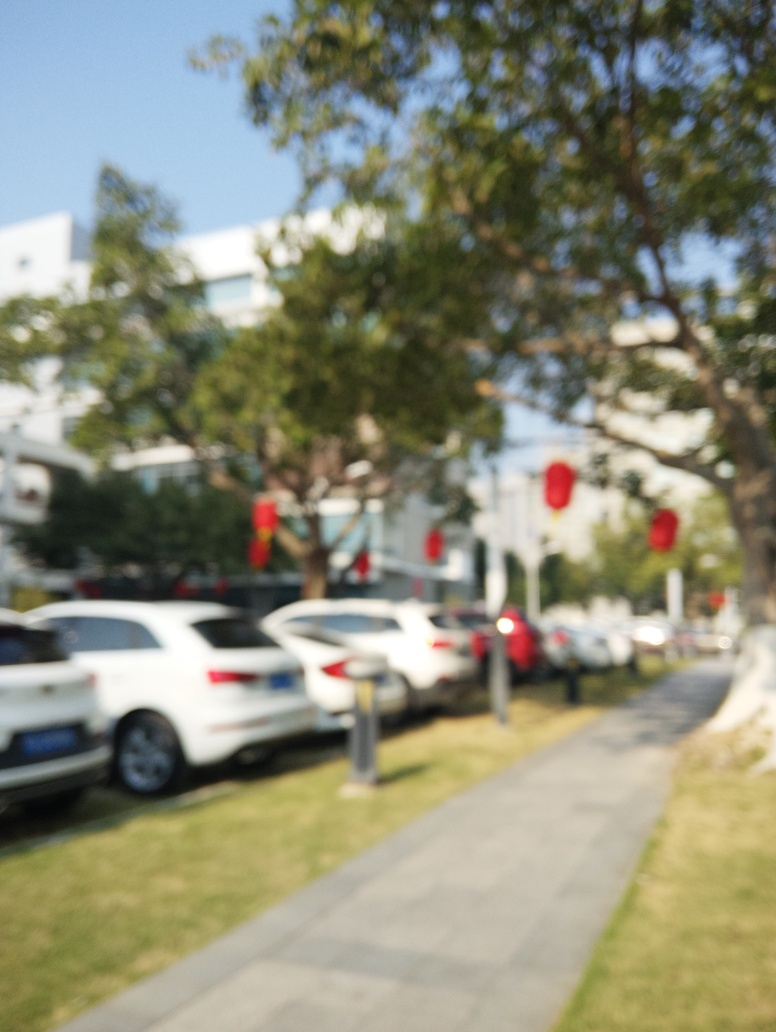What could be the potential subjects of interest in this image? Potential subjects of interest might include the row of parked cars, the vibrant decorations hanging from the trees, or the natural and urban elements juxtaposed along the walking path. However, due to the image's blur, these features are not distinctly visible. 